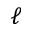<formula> <loc_0><loc_0><loc_500><loc_500>\ell</formula> 